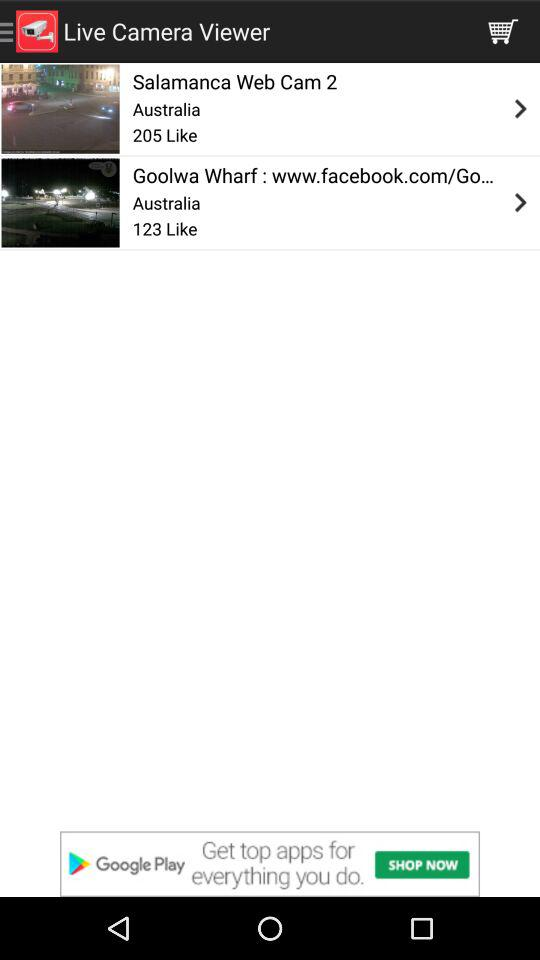In what country is "Salamanca Web Cam 2" located? "Salamanca Web Cam 2" is located in Australia. 